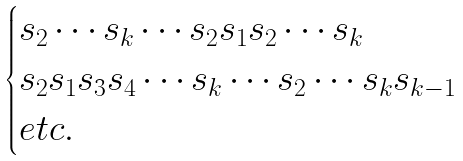<formula> <loc_0><loc_0><loc_500><loc_500>\begin{cases} s _ { 2 } \cdots s _ { k } \cdots s _ { 2 } s _ { 1 } s _ { 2 } \cdots s _ { k } \\ s _ { 2 } s _ { 1 } s _ { 3 } s _ { 4 } \cdots s _ { k } \cdots s _ { 2 } \cdots s _ { k } s _ { k - 1 } \\ e t c . \end{cases}</formula> 